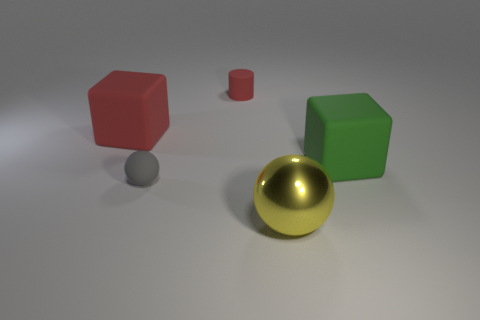What color is the metallic object?
Offer a very short reply. Yellow. Does the small matte ball have the same color as the large metal thing?
Your answer should be very brief. No. What number of small matte things are in front of the tiny thing that is to the right of the gray rubber thing?
Keep it short and to the point. 1. There is a rubber thing that is left of the metal sphere and to the right of the gray rubber object; what is its size?
Provide a succinct answer. Small. What is the material of the object left of the small gray object?
Provide a short and direct response. Rubber. Are there any small green matte things that have the same shape as the big green thing?
Your answer should be very brief. No. How many shiny objects have the same shape as the small gray rubber thing?
Make the answer very short. 1. There is a matte cube that is behind the green matte cube; does it have the same size as the object in front of the gray matte object?
Keep it short and to the point. Yes. There is a tiny thing that is in front of the large rubber block that is to the right of the gray sphere; what shape is it?
Your answer should be compact. Sphere. Are there the same number of small red cylinders in front of the big red matte object and big metallic spheres?
Your answer should be compact. No. 